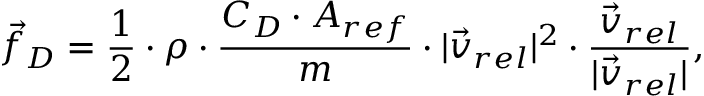Convert formula to latex. <formula><loc_0><loc_0><loc_500><loc_500>\vec { f } _ { D } = \frac { 1 } { 2 } \cdot \rho \cdot \frac { C _ { D } \cdot A _ { r e f } } { m } \cdot | \vec { v } _ { r e l } | ^ { 2 } \cdot \frac { \vec { v } _ { r e l } } { | \vec { v } _ { r e l } | } ,</formula> 